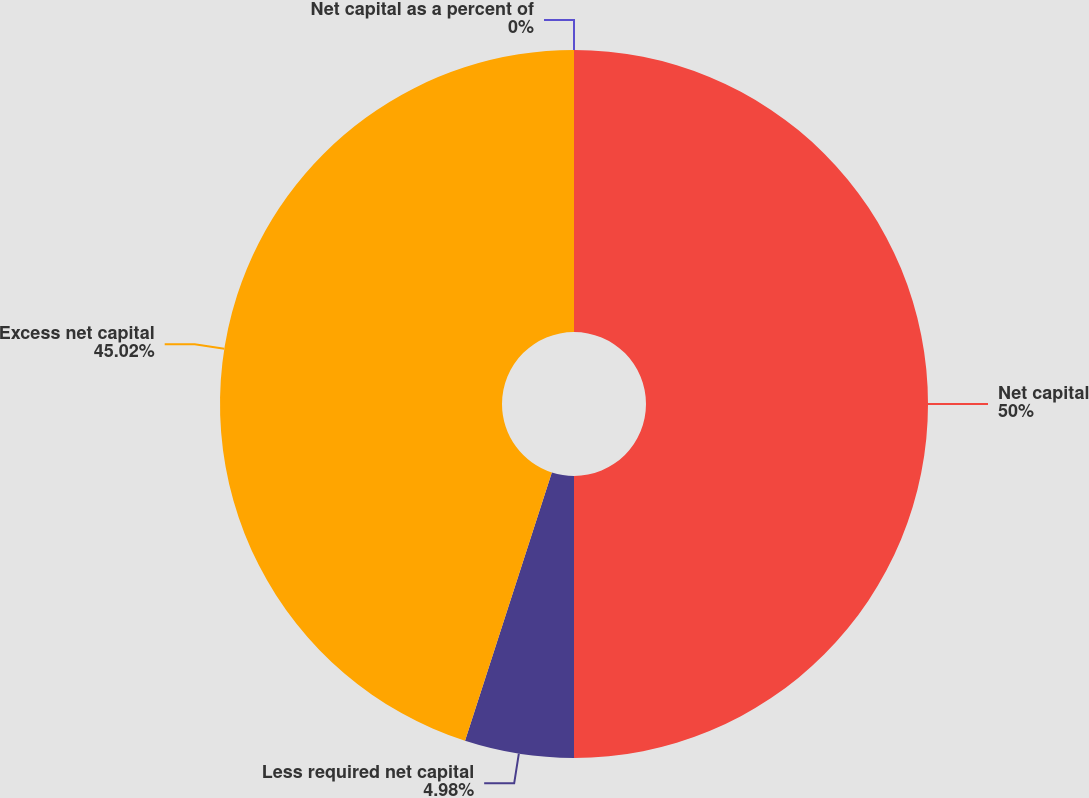Convert chart. <chart><loc_0><loc_0><loc_500><loc_500><pie_chart><fcel>Net capital as a percent of<fcel>Net capital<fcel>Less required net capital<fcel>Excess net capital<nl><fcel>0.0%<fcel>50.0%<fcel>4.98%<fcel>45.02%<nl></chart> 